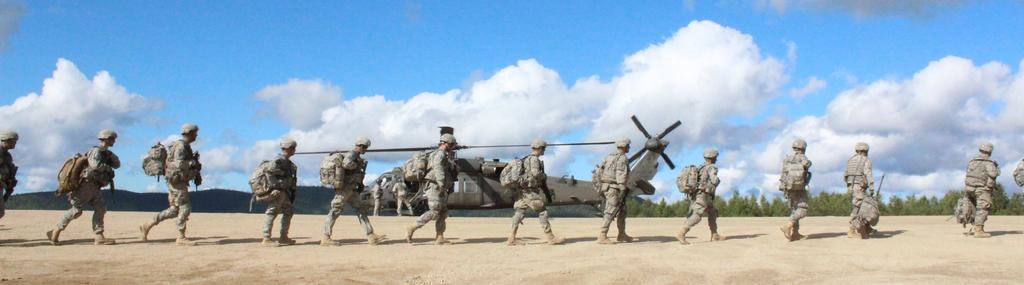What are the men in the image wearing? The men in the image are wearing uniforms. What are the men doing in the image? The men are walking in a row on the sand. What can be seen in the image besides the men? There is a helicopter in the image. What is visible in the background of the image? There are trees, hills, and the sky visible in the background of the image. What is the condition of the sky in the image? The sky is visible in the background of the image, and clouds are present. What type of cushion is being used by the helicopter in the image? There is no cushion present in the image, as the helicopter is not shown using any cushion. 